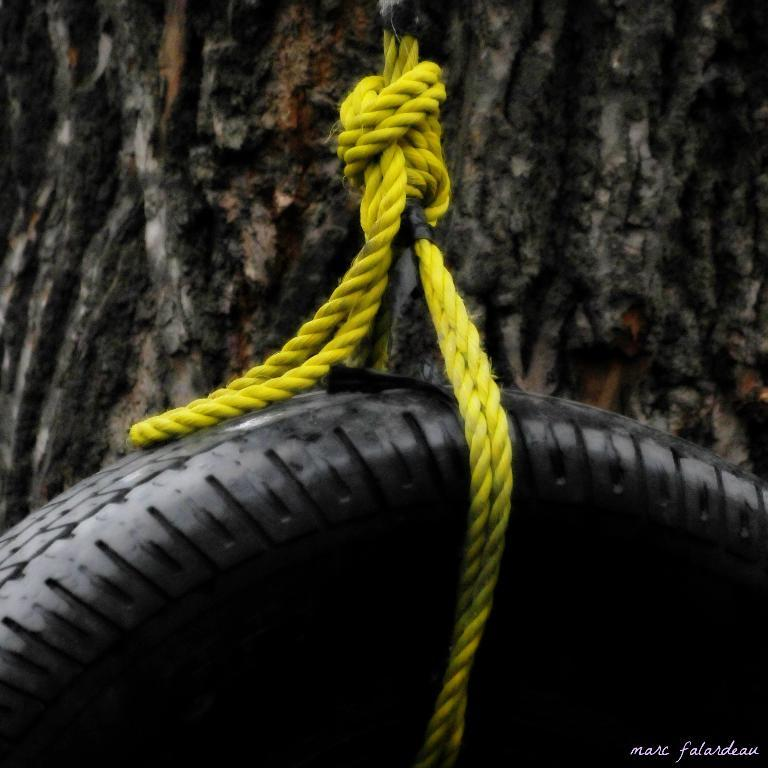What object is the main focus of the image? There is a tyre in the image. How is the tyre positioned or secured? The tyre is tied with a rope. What can be seen in the background of the image? There is a tree trunk in the background of the image. Is there any text or writing in the image? Yes, there is text visible in the bottom right corner of the image. What type of verse can be heard being recited by the turkey in the image? A: There is no turkey or verse present in the image; it features a tyre tied with a rope and a tree trunk in the background. 